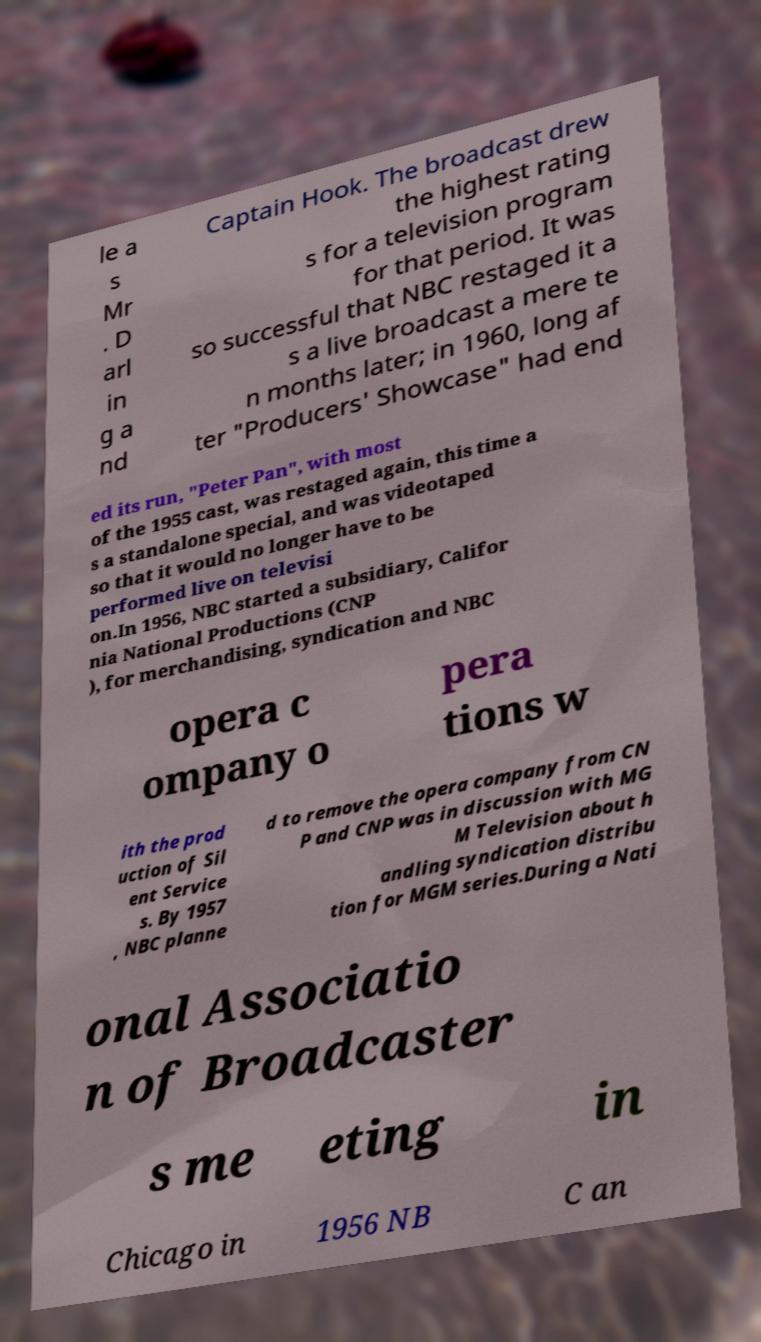What messages or text are displayed in this image? I need them in a readable, typed format. le a s Mr . D arl in g a nd Captain Hook. The broadcast drew the highest rating s for a television program for that period. It was so successful that NBC restaged it a s a live broadcast a mere te n months later; in 1960, long af ter "Producers' Showcase" had end ed its run, "Peter Pan", with most of the 1955 cast, was restaged again, this time a s a standalone special, and was videotaped so that it would no longer have to be performed live on televisi on.In 1956, NBC started a subsidiary, Califor nia National Productions (CNP ), for merchandising, syndication and NBC opera c ompany o pera tions w ith the prod uction of Sil ent Service s. By 1957 , NBC planne d to remove the opera company from CN P and CNP was in discussion with MG M Television about h andling syndication distribu tion for MGM series.During a Nati onal Associatio n of Broadcaster s me eting in Chicago in 1956 NB C an 